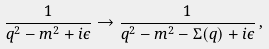Convert formula to latex. <formula><loc_0><loc_0><loc_500><loc_500>\frac { 1 } { q ^ { 2 } - m ^ { 2 } + i \epsilon } \rightarrow \frac { 1 } { q ^ { 2 } - m ^ { 2 } - \Sigma ( q ) + i \epsilon } \, ,</formula> 